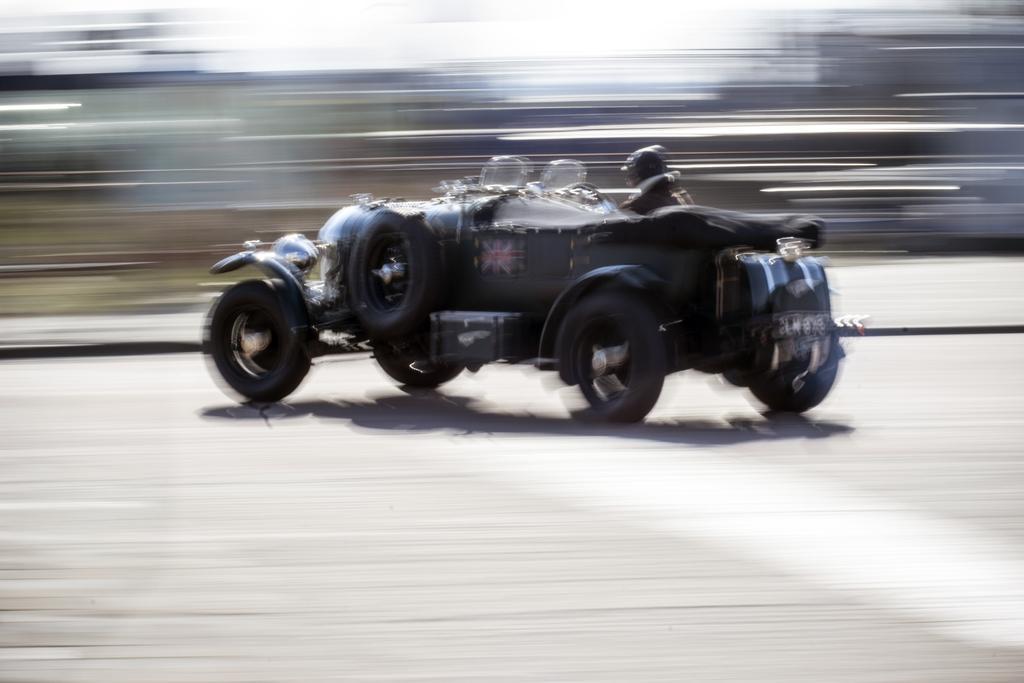How would you summarize this image in a sentence or two? In the foreground of this image, there is a man on a vehicle which is on the road and the background image is blur. 